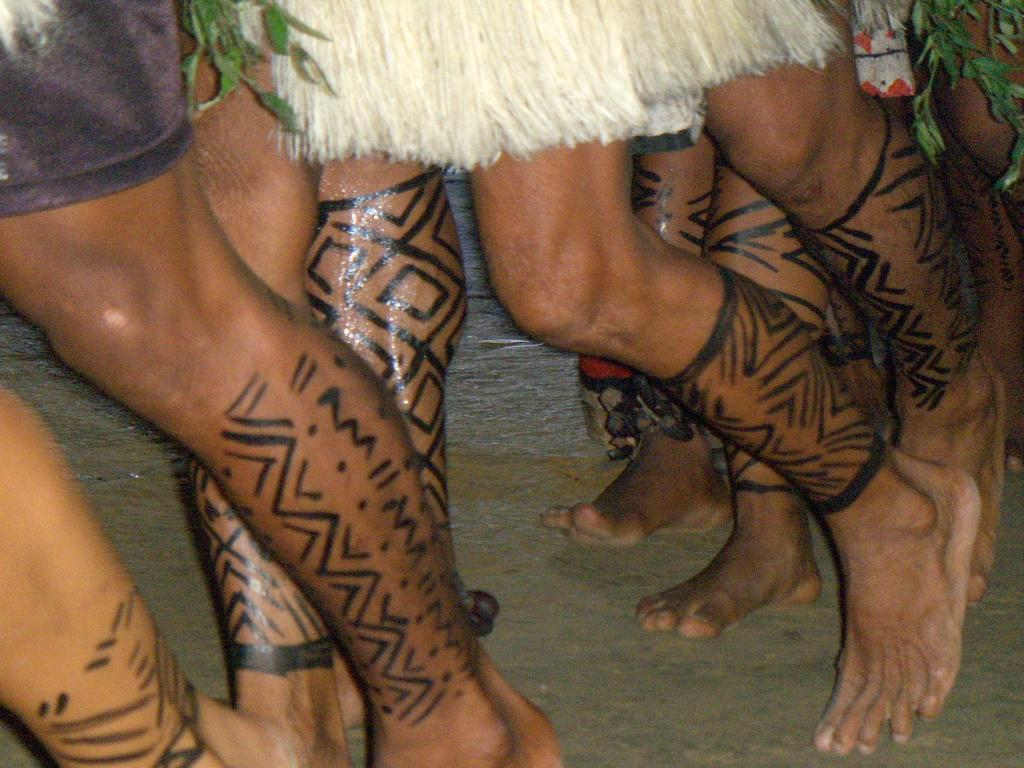Who is present in the image? There are people in the image. What are the people wearing? The people are wearing costumes. What can be seen at the bottom of the image? There is a road visible at the bottom of the image. Reasoning: Let's think step by step by step in order to produce the conversation. We start by identifying the main subjects in the image, which are the people. Then, we describe what the people are wearing, which is costumes. Finally, we mention the road visible at the bottom of the image. Each question is designed to elicit a specific detail about the image that is known from the provided facts. Absurd Question/Answer: What is the taste of the office in the image? There is no office present in the image, so it cannot be tasted. 